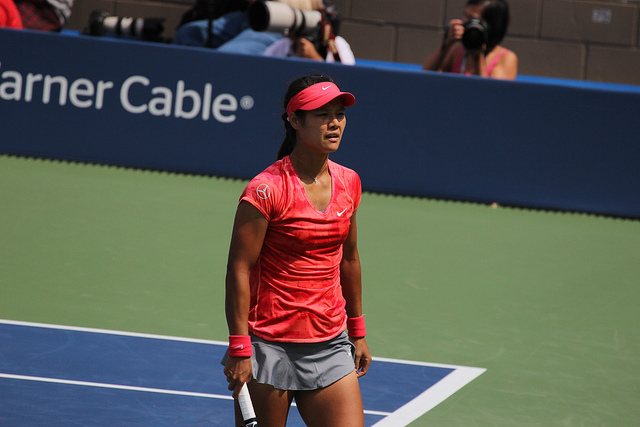Please transcribe the text information in this image. arner Cable 